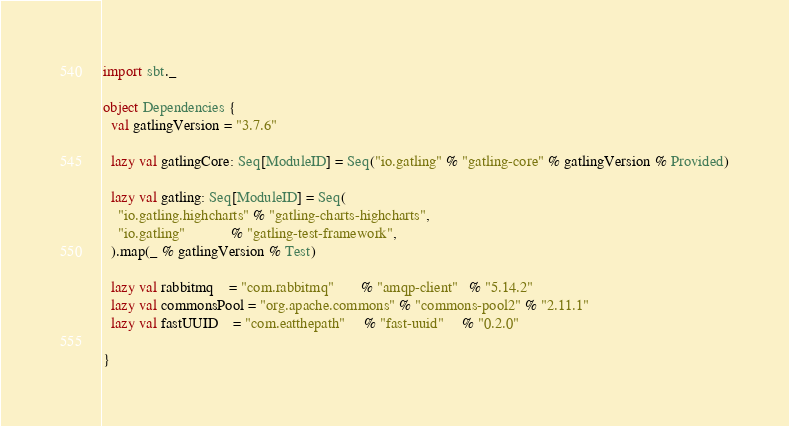<code> <loc_0><loc_0><loc_500><loc_500><_Scala_>import sbt._

object Dependencies {
  val gatlingVersion = "3.7.6"

  lazy val gatlingCore: Seq[ModuleID] = Seq("io.gatling" % "gatling-core" % gatlingVersion % Provided)

  lazy val gatling: Seq[ModuleID] = Seq(
    "io.gatling.highcharts" % "gatling-charts-highcharts",
    "io.gatling"            % "gatling-test-framework",
  ).map(_ % gatlingVersion % Test)

  lazy val rabbitmq    = "com.rabbitmq"       % "amqp-client"   % "5.14.2"
  lazy val commonsPool = "org.apache.commons" % "commons-pool2" % "2.11.1"
  lazy val fastUUID    = "com.eatthepath"     % "fast-uuid"     % "0.2.0"

}
</code> 